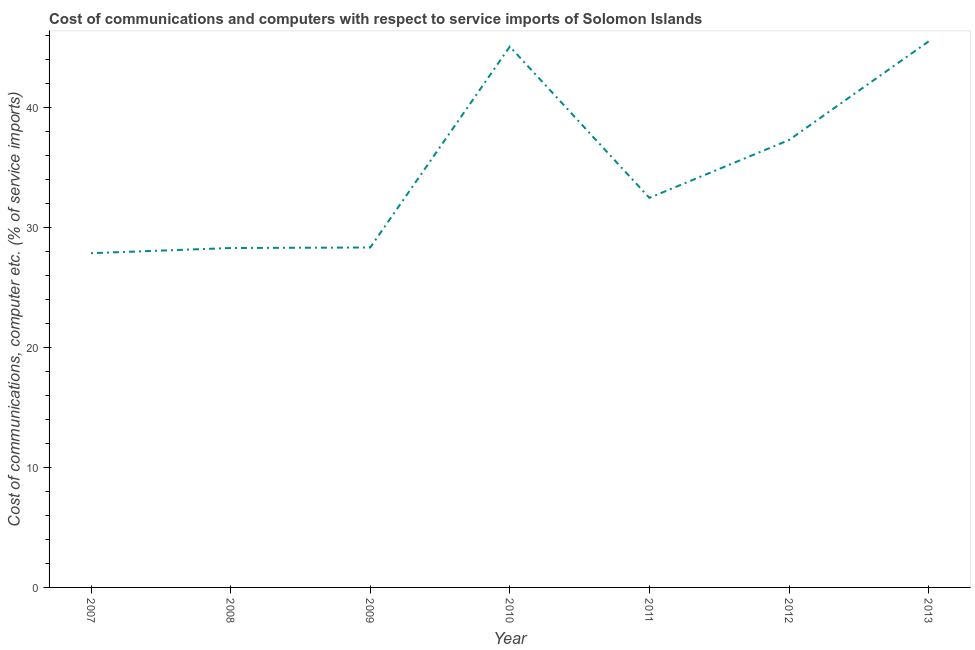What is the cost of communications and computer in 2011?
Ensure brevity in your answer.  32.47. Across all years, what is the maximum cost of communications and computer?
Your answer should be very brief. 45.51. Across all years, what is the minimum cost of communications and computer?
Provide a succinct answer. 27.86. What is the sum of the cost of communications and computer?
Provide a succinct answer. 244.85. What is the difference between the cost of communications and computer in 2009 and 2013?
Offer a very short reply. -17.18. What is the average cost of communications and computer per year?
Provide a succinct answer. 34.98. What is the median cost of communications and computer?
Your response must be concise. 32.47. In how many years, is the cost of communications and computer greater than 4 %?
Provide a short and direct response. 7. Do a majority of the years between 2010 and 2008 (inclusive) have cost of communications and computer greater than 10 %?
Provide a succinct answer. No. What is the ratio of the cost of communications and computer in 2012 to that in 2013?
Your response must be concise. 0.82. Is the difference between the cost of communications and computer in 2007 and 2012 greater than the difference between any two years?
Your response must be concise. No. What is the difference between the highest and the second highest cost of communications and computer?
Provide a succinct answer. 0.43. Is the sum of the cost of communications and computer in 2008 and 2012 greater than the maximum cost of communications and computer across all years?
Provide a succinct answer. Yes. What is the difference between the highest and the lowest cost of communications and computer?
Your response must be concise. 17.65. Does the cost of communications and computer monotonically increase over the years?
Offer a terse response. No. How many years are there in the graph?
Offer a terse response. 7. What is the difference between two consecutive major ticks on the Y-axis?
Provide a succinct answer. 10. Are the values on the major ticks of Y-axis written in scientific E-notation?
Provide a short and direct response. No. Does the graph contain any zero values?
Keep it short and to the point. No. What is the title of the graph?
Your answer should be very brief. Cost of communications and computers with respect to service imports of Solomon Islands. What is the label or title of the Y-axis?
Provide a short and direct response. Cost of communications, computer etc. (% of service imports). What is the Cost of communications, computer etc. (% of service imports) in 2007?
Provide a succinct answer. 27.86. What is the Cost of communications, computer etc. (% of service imports) in 2008?
Your answer should be very brief. 28.29. What is the Cost of communications, computer etc. (% of service imports) of 2009?
Make the answer very short. 28.34. What is the Cost of communications, computer etc. (% of service imports) in 2010?
Offer a terse response. 45.08. What is the Cost of communications, computer etc. (% of service imports) of 2011?
Your response must be concise. 32.47. What is the Cost of communications, computer etc. (% of service imports) of 2012?
Make the answer very short. 37.29. What is the Cost of communications, computer etc. (% of service imports) of 2013?
Your answer should be compact. 45.51. What is the difference between the Cost of communications, computer etc. (% of service imports) in 2007 and 2008?
Your answer should be very brief. -0.43. What is the difference between the Cost of communications, computer etc. (% of service imports) in 2007 and 2009?
Your answer should be very brief. -0.47. What is the difference between the Cost of communications, computer etc. (% of service imports) in 2007 and 2010?
Make the answer very short. -17.22. What is the difference between the Cost of communications, computer etc. (% of service imports) in 2007 and 2011?
Make the answer very short. -4.61. What is the difference between the Cost of communications, computer etc. (% of service imports) in 2007 and 2012?
Offer a terse response. -9.43. What is the difference between the Cost of communications, computer etc. (% of service imports) in 2007 and 2013?
Your response must be concise. -17.65. What is the difference between the Cost of communications, computer etc. (% of service imports) in 2008 and 2009?
Provide a short and direct response. -0.04. What is the difference between the Cost of communications, computer etc. (% of service imports) in 2008 and 2010?
Keep it short and to the point. -16.79. What is the difference between the Cost of communications, computer etc. (% of service imports) in 2008 and 2011?
Offer a terse response. -4.18. What is the difference between the Cost of communications, computer etc. (% of service imports) in 2008 and 2012?
Make the answer very short. -9. What is the difference between the Cost of communications, computer etc. (% of service imports) in 2008 and 2013?
Give a very brief answer. -17.22. What is the difference between the Cost of communications, computer etc. (% of service imports) in 2009 and 2010?
Your answer should be very brief. -16.75. What is the difference between the Cost of communications, computer etc. (% of service imports) in 2009 and 2011?
Your answer should be very brief. -4.14. What is the difference between the Cost of communications, computer etc. (% of service imports) in 2009 and 2012?
Offer a very short reply. -8.96. What is the difference between the Cost of communications, computer etc. (% of service imports) in 2009 and 2013?
Ensure brevity in your answer.  -17.18. What is the difference between the Cost of communications, computer etc. (% of service imports) in 2010 and 2011?
Your answer should be very brief. 12.61. What is the difference between the Cost of communications, computer etc. (% of service imports) in 2010 and 2012?
Your response must be concise. 7.79. What is the difference between the Cost of communications, computer etc. (% of service imports) in 2010 and 2013?
Keep it short and to the point. -0.43. What is the difference between the Cost of communications, computer etc. (% of service imports) in 2011 and 2012?
Your response must be concise. -4.82. What is the difference between the Cost of communications, computer etc. (% of service imports) in 2011 and 2013?
Offer a terse response. -13.04. What is the difference between the Cost of communications, computer etc. (% of service imports) in 2012 and 2013?
Your answer should be compact. -8.22. What is the ratio of the Cost of communications, computer etc. (% of service imports) in 2007 to that in 2008?
Your response must be concise. 0.98. What is the ratio of the Cost of communications, computer etc. (% of service imports) in 2007 to that in 2010?
Provide a short and direct response. 0.62. What is the ratio of the Cost of communications, computer etc. (% of service imports) in 2007 to that in 2011?
Offer a terse response. 0.86. What is the ratio of the Cost of communications, computer etc. (% of service imports) in 2007 to that in 2012?
Your response must be concise. 0.75. What is the ratio of the Cost of communications, computer etc. (% of service imports) in 2007 to that in 2013?
Offer a terse response. 0.61. What is the ratio of the Cost of communications, computer etc. (% of service imports) in 2008 to that in 2009?
Your answer should be very brief. 1. What is the ratio of the Cost of communications, computer etc. (% of service imports) in 2008 to that in 2010?
Offer a terse response. 0.63. What is the ratio of the Cost of communications, computer etc. (% of service imports) in 2008 to that in 2011?
Make the answer very short. 0.87. What is the ratio of the Cost of communications, computer etc. (% of service imports) in 2008 to that in 2012?
Provide a succinct answer. 0.76. What is the ratio of the Cost of communications, computer etc. (% of service imports) in 2008 to that in 2013?
Provide a short and direct response. 0.62. What is the ratio of the Cost of communications, computer etc. (% of service imports) in 2009 to that in 2010?
Keep it short and to the point. 0.63. What is the ratio of the Cost of communications, computer etc. (% of service imports) in 2009 to that in 2011?
Provide a short and direct response. 0.87. What is the ratio of the Cost of communications, computer etc. (% of service imports) in 2009 to that in 2012?
Provide a short and direct response. 0.76. What is the ratio of the Cost of communications, computer etc. (% of service imports) in 2009 to that in 2013?
Offer a terse response. 0.62. What is the ratio of the Cost of communications, computer etc. (% of service imports) in 2010 to that in 2011?
Give a very brief answer. 1.39. What is the ratio of the Cost of communications, computer etc. (% of service imports) in 2010 to that in 2012?
Provide a short and direct response. 1.21. What is the ratio of the Cost of communications, computer etc. (% of service imports) in 2011 to that in 2012?
Ensure brevity in your answer.  0.87. What is the ratio of the Cost of communications, computer etc. (% of service imports) in 2011 to that in 2013?
Offer a terse response. 0.71. What is the ratio of the Cost of communications, computer etc. (% of service imports) in 2012 to that in 2013?
Your response must be concise. 0.82. 